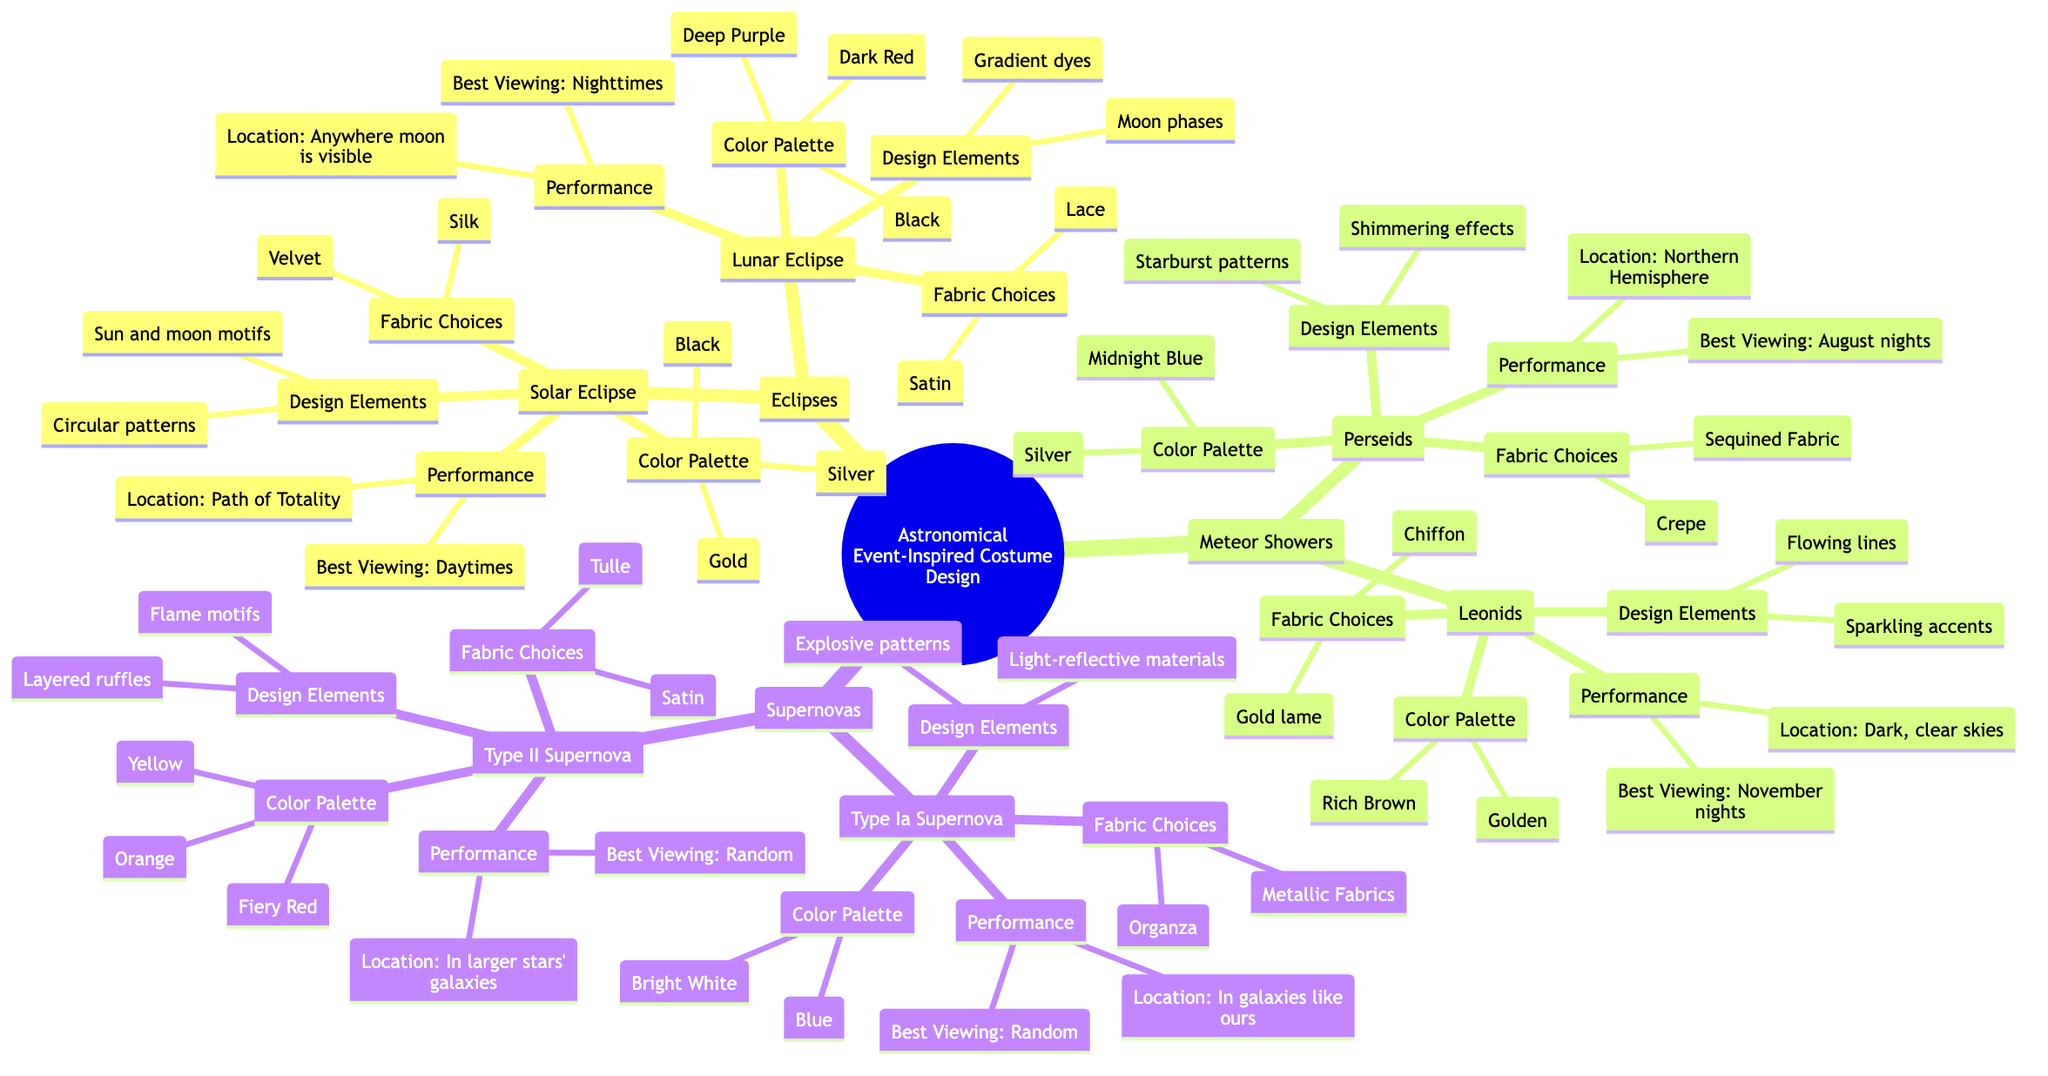What are the color palettes for Solar Eclipse costumes? The diagram under the Solar Eclipse node lists the color palette, which includes Black, Gold, and Silver as the specified colors for the costume design.
Answer: Black, Gold, Silver How many types of Supernova costumes are mentioned in the diagram? The Supernovas section lists two types of supernova costumes: Type Ia Supernova and Type II Supernova. Therefore, there are two types mentioned.
Answer: 2 What are the fabric choices for the Lunar Eclipse design? The diagram under the Lunar Eclipse node specifies two fabric choices: Satin and Lace. This information is clearly stated in that section.
Answer: Satin, Lace What is the best viewing time for the Perseids meteor shower? The diagram indicates that the best viewing time for the Perseids is August nights. This piece of information can be found under the Perseids section.
Answer: August nights Which design elements are associated with Type II Supernova costumes? The Type II Supernova node includes "Flame motifs" and "Layered ruffles" as the specific design elements, which can be easily found in that section of the diagram.
Answer: Flame motifs, Layered ruffles How are the color palettes of Solar and Lunar Eclipses different? The Solar Eclipse has a color palette of Black, Gold, and Silver, while the Lunar Eclipse's palette features Dark Red, Deep Purple, and Black. This comparison requires looking at both sections and assessing their differences.
Answer: Different colors Where should one be to view a Solar Eclipse optimally? The diagram specifies that the optimal location to view a Solar Eclipse is the Path of Totality, which is outlined in the performance section under the Solar Eclipse node.
Answer: Path of Totality What are the optimal locations for viewing Leonids meteor showers? The diagram states that the optimal location for viewing Leonids is anywhere with dark, clear skies, as seen in the performance schedule for Leonids.
Answer: Dark, clear skies What design elements relate to the meteor shower Perseids? The Perseids section of the diagram notes "Starburst patterns" and "Shimmering effects" as the design elements. Collecting this information involves examining the specific elements listed for Perseids.
Answer: Starburst patterns, Shimmering effects 